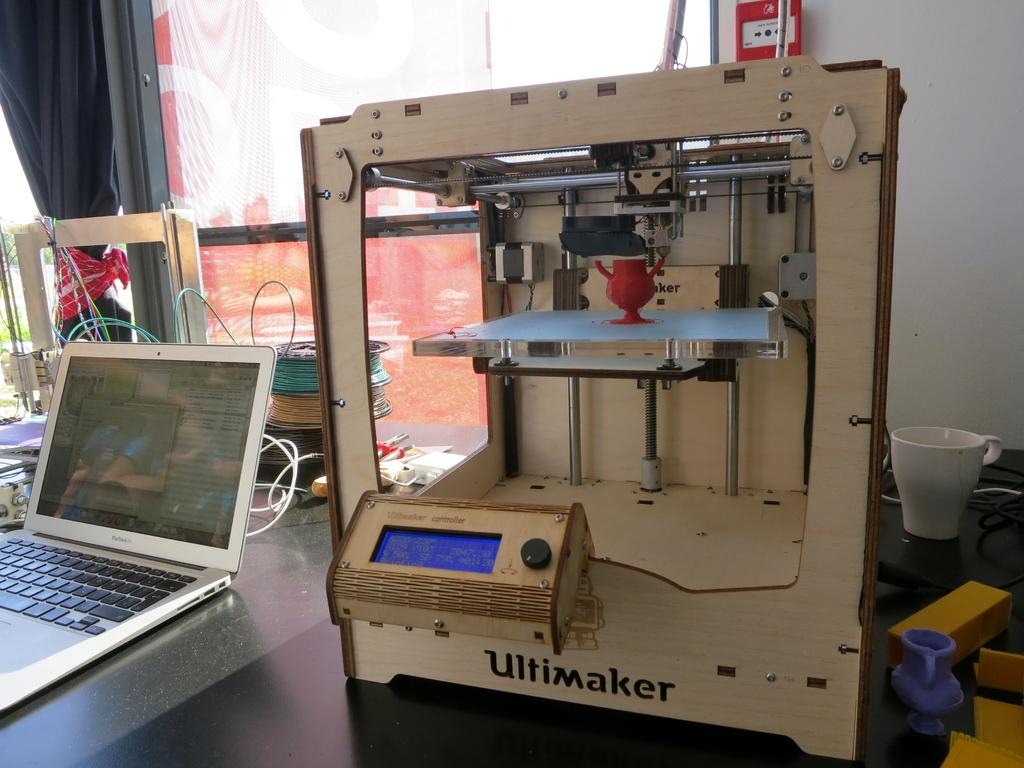What electronic device is on the table in the image? There is a laptop on the table in the image. What other electronic device is on the table? There is an electrical machine with "Ultimaker" written on it on the table. What type of beverage might be served in the cup on the table? There is a tea cup on the table, which suggests that tea might be served in it. What type of decorative item is on the table? There is a small vase on the table. What might be used to connect the electronic devices on the table? There are wires visible in the image, which might be used to connect the devices. How many crows are sitting on the laptop in the image? There are no crows present in the image; it features a laptop, an Ultimaker machine, a tea cup, a small vase, and wires on a table. What type of coal is used to power the laptop in the image? The laptop in the image is powered by electricity, not coal. 